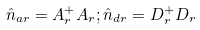Convert formula to latex. <formula><loc_0><loc_0><loc_500><loc_500>\hat { n } _ { a r } = A _ { r } ^ { + } A _ { r } ; \hat { n } _ { d r } = D _ { r } ^ { + } D _ { r }</formula> 